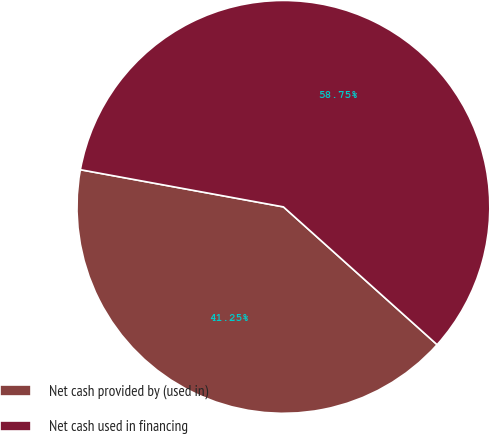Convert chart. <chart><loc_0><loc_0><loc_500><loc_500><pie_chart><fcel>Net cash provided by (used in)<fcel>Net cash used in financing<nl><fcel>41.25%<fcel>58.75%<nl></chart> 